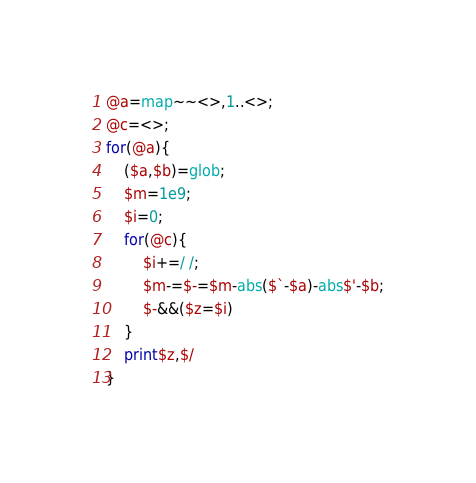Convert code to text. <code><loc_0><loc_0><loc_500><loc_500><_Perl_>@a=map~~<>,1..<>;
@c=<>;
for(@a){
	($a,$b)=glob;
	$m=1e9;
	$i=0;
	for(@c){
		$i+=/ /;
		$m-=$-=$m-abs($`-$a)-abs$'-$b;
		$-&&($z=$i)
	}
	print$z,$/
}
</code> 